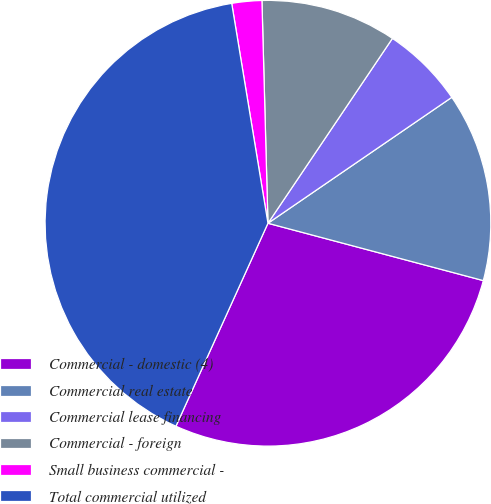Convert chart. <chart><loc_0><loc_0><loc_500><loc_500><pie_chart><fcel>Commercial - domestic (4)<fcel>Commercial real estate<fcel>Commercial lease financing<fcel>Commercial - foreign<fcel>Small business commercial -<fcel>Total commercial utilized<nl><fcel>27.63%<fcel>13.7%<fcel>6.01%<fcel>9.86%<fcel>2.17%<fcel>40.62%<nl></chart> 